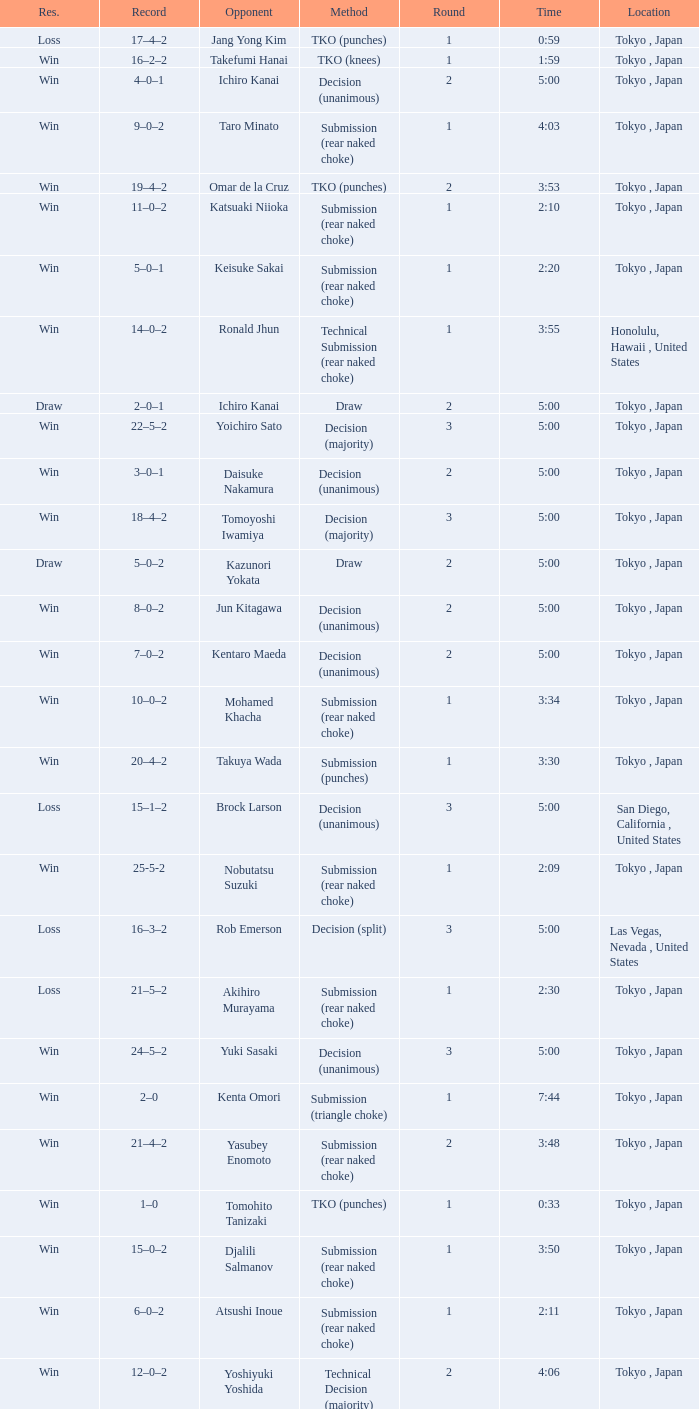What is the total number of rounds when Drew Fickett was the opponent and the time is 5:00? 1.0. 